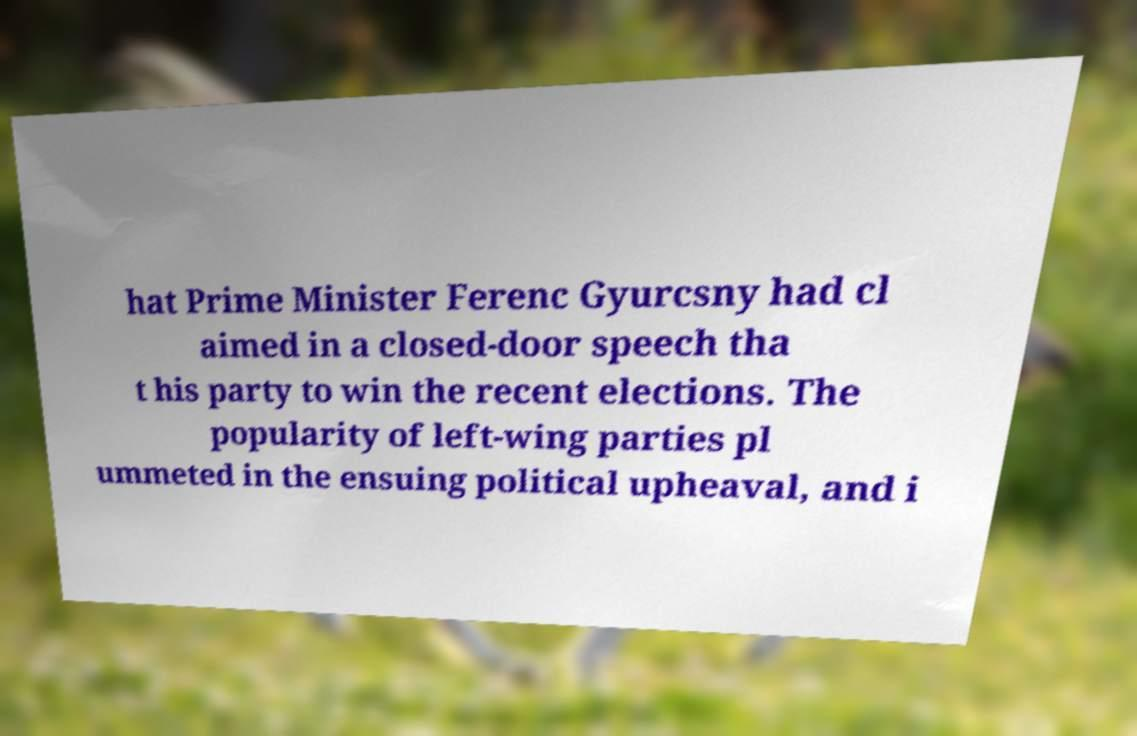Please identify and transcribe the text found in this image. hat Prime Minister Ferenc Gyurcsny had cl aimed in a closed-door speech tha t his party to win the recent elections. The popularity of left-wing parties pl ummeted in the ensuing political upheaval, and i 